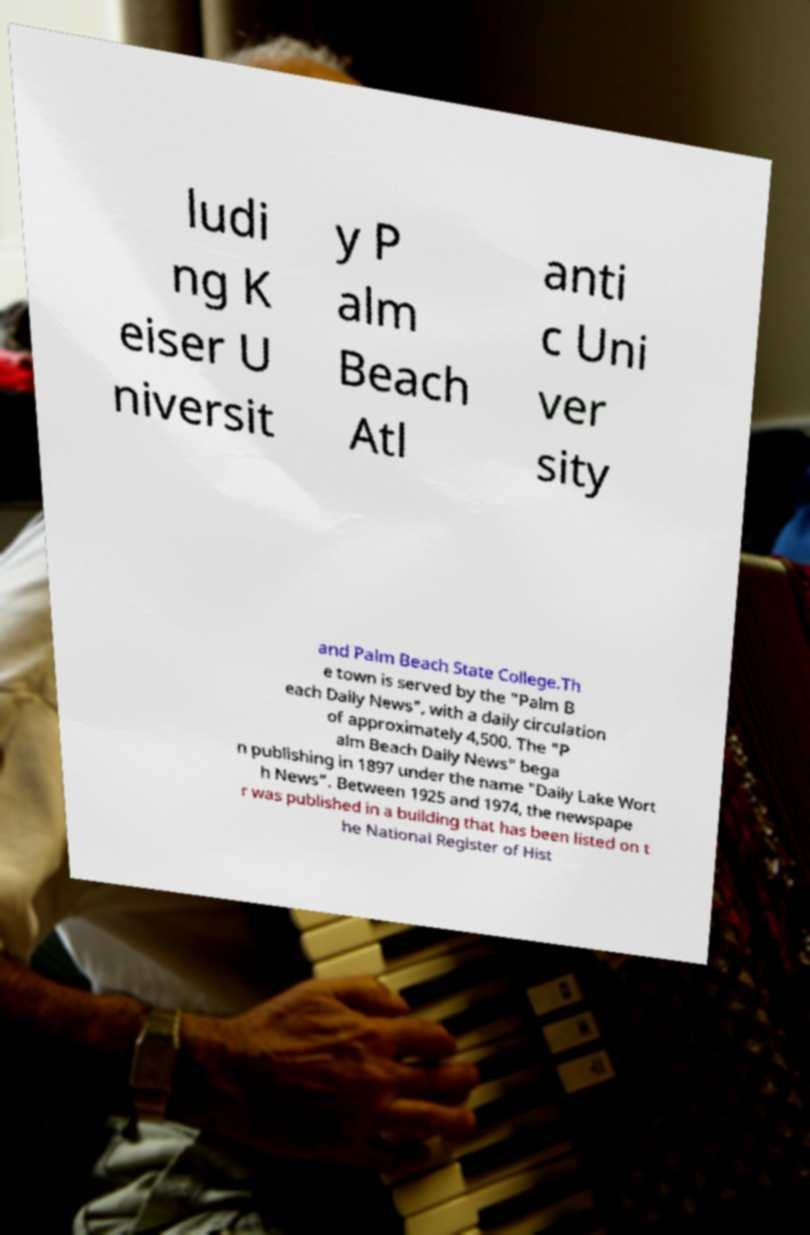For documentation purposes, I need the text within this image transcribed. Could you provide that? ludi ng K eiser U niversit y P alm Beach Atl anti c Uni ver sity and Palm Beach State College.Th e town is served by the "Palm B each Daily News", with a daily circulation of approximately 4,500. The "P alm Beach Daily News" bega n publishing in 1897 under the name "Daily Lake Wort h News". Between 1925 and 1974, the newspape r was published in a building that has been listed on t he National Register of Hist 